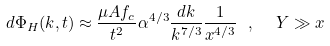Convert formula to latex. <formula><loc_0><loc_0><loc_500><loc_500>d \Phi _ { H } ( k , t ) \approx \frac { \mu A f _ { c } } { t ^ { 2 } } \alpha ^ { 4 / 3 } \frac { d k } { k ^ { 7 / 3 } } \frac { 1 } { x ^ { 4 / 3 } } \ , \ \ Y \gg x</formula> 